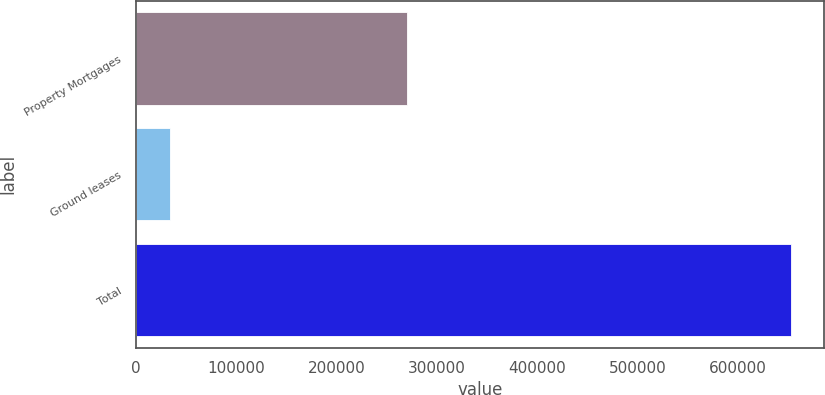Convert chart. <chart><loc_0><loc_0><loc_500><loc_500><bar_chart><fcel>Property Mortgages<fcel>Ground leases<fcel>Total<nl><fcel>270382<fcel>33429<fcel>653245<nl></chart> 